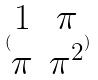<formula> <loc_0><loc_0><loc_500><loc_500>( \begin{matrix} 1 & \pi \\ \pi & \pi ^ { 2 } \end{matrix} )</formula> 